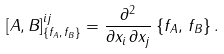Convert formula to latex. <formula><loc_0><loc_0><loc_500><loc_500>[ A , B ] _ { \{ f _ { A } , \, f _ { B } \} } ^ { i j } = \frac { \partial ^ { 2 } } { \partial x _ { i } \, \partial x _ { j } } \, \{ f _ { A } , \, f _ { B } \} \, .</formula> 